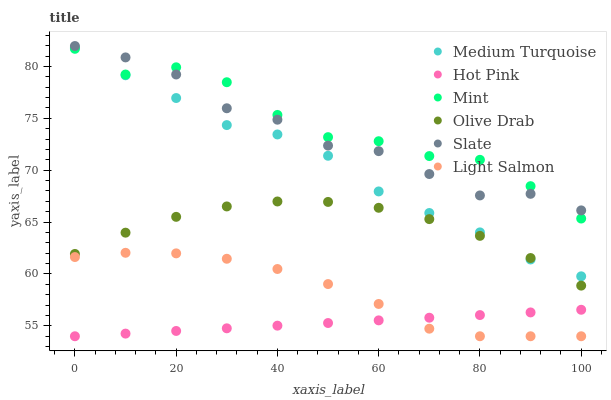Does Hot Pink have the minimum area under the curve?
Answer yes or no. Yes. Does Mint have the maximum area under the curve?
Answer yes or no. Yes. Does Slate have the minimum area under the curve?
Answer yes or no. No. Does Slate have the maximum area under the curve?
Answer yes or no. No. Is Hot Pink the smoothest?
Answer yes or no. Yes. Is Mint the roughest?
Answer yes or no. Yes. Is Slate the smoothest?
Answer yes or no. No. Is Slate the roughest?
Answer yes or no. No. Does Light Salmon have the lowest value?
Answer yes or no. Yes. Does Slate have the lowest value?
Answer yes or no. No. Does Slate have the highest value?
Answer yes or no. Yes. Does Hot Pink have the highest value?
Answer yes or no. No. Is Light Salmon less than Mint?
Answer yes or no. Yes. Is Slate greater than Light Salmon?
Answer yes or no. Yes. Does Hot Pink intersect Light Salmon?
Answer yes or no. Yes. Is Hot Pink less than Light Salmon?
Answer yes or no. No. Is Hot Pink greater than Light Salmon?
Answer yes or no. No. Does Light Salmon intersect Mint?
Answer yes or no. No. 